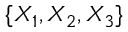<formula> <loc_0><loc_0><loc_500><loc_500>\{ X _ { 1 } , X _ { 2 } , X _ { 3 } \}</formula> 